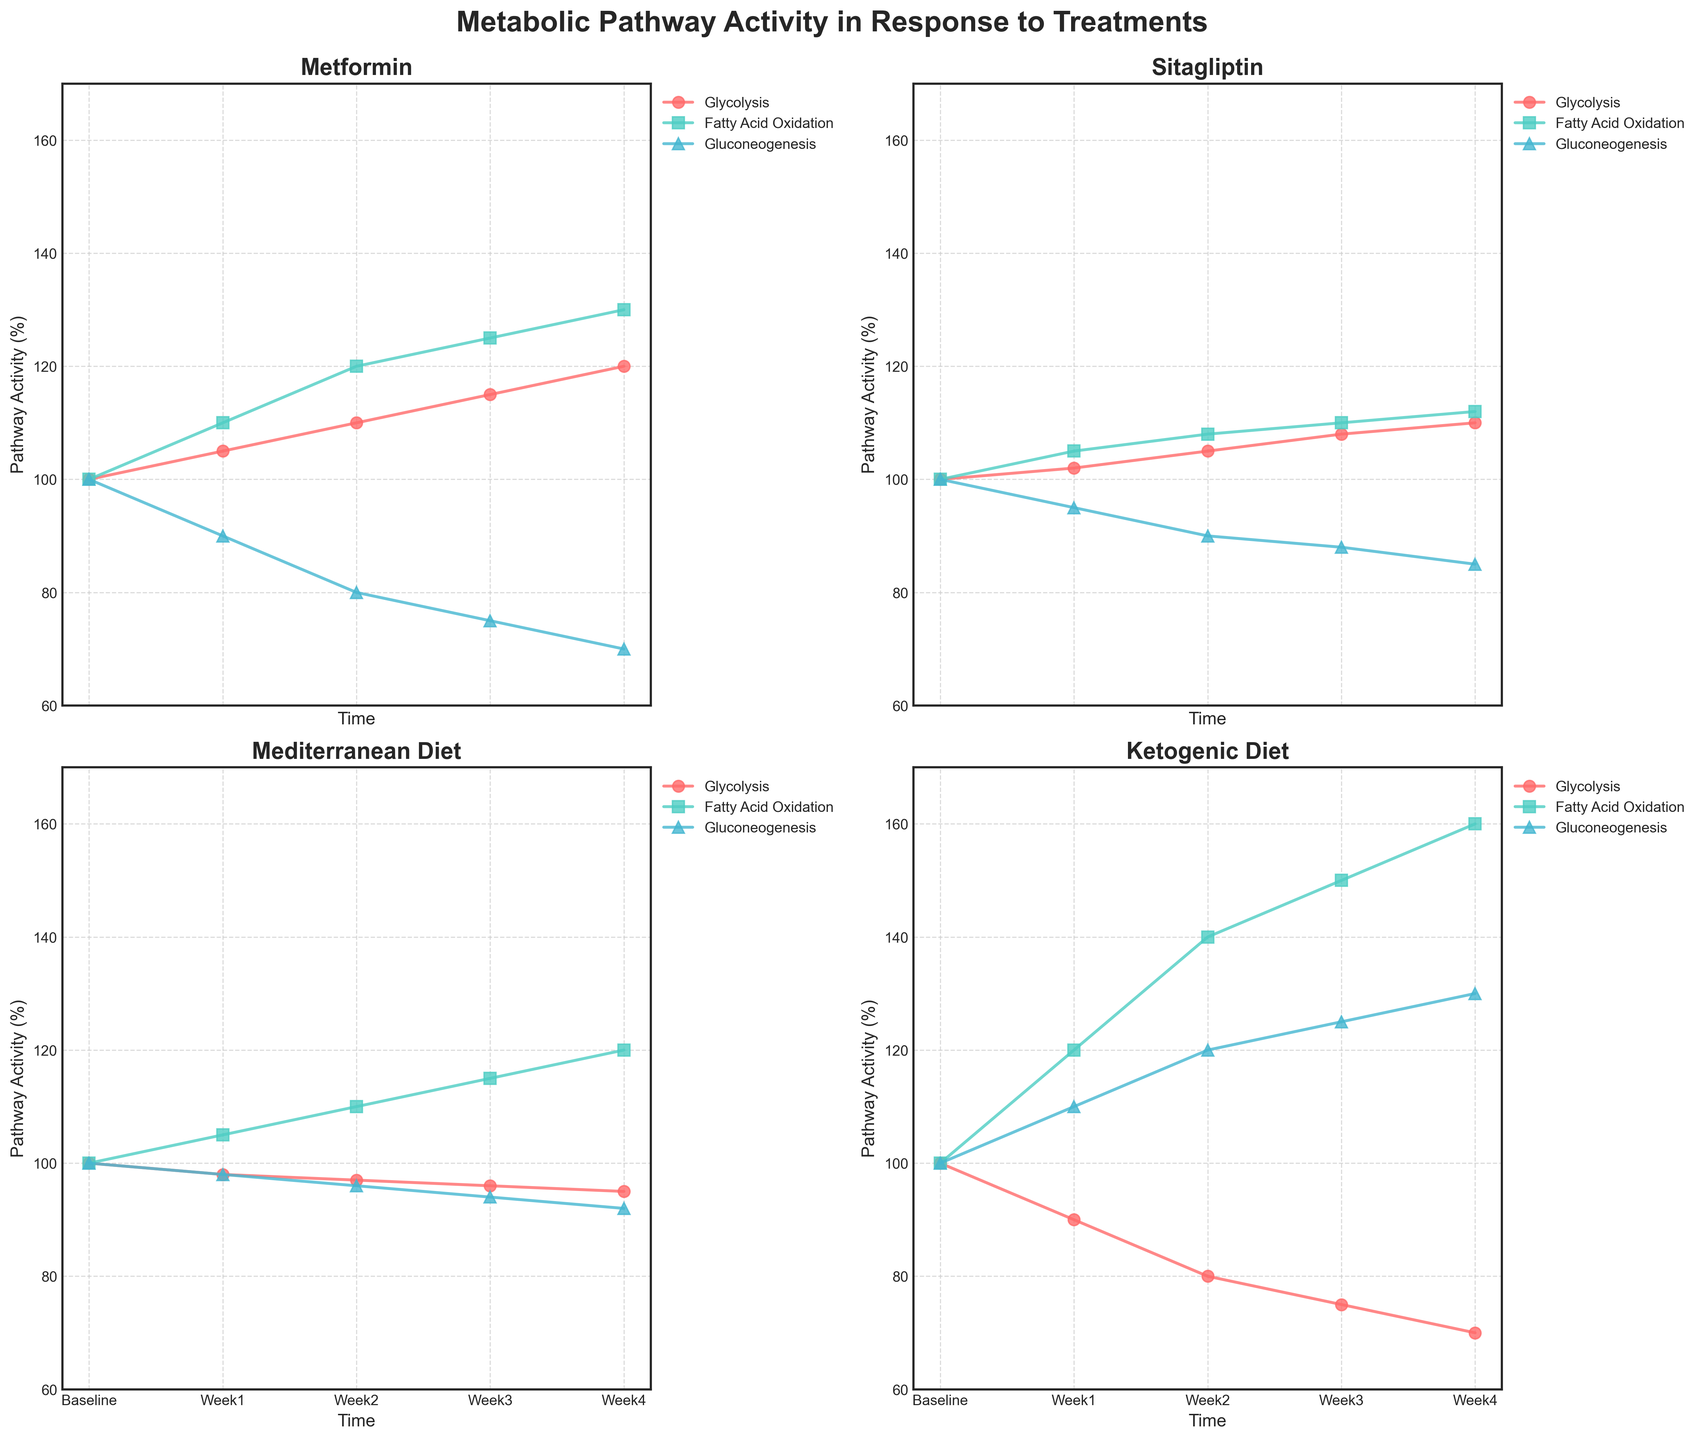What is the y-axis label in all subplots? All subplots have the y-axis labeled as 'Pathway Activity (%)', indicating the activity level of various metabolic pathways as a percentage.
Answer: Pathway Activity (%) Which treatment shows the greatest increase in Glycolysis activity by Week 4? Comparing the Glycolysis activity for all treatments at Week 4: Metformin (120), Sitagliptin (110), Mediterranean Diet (95), and Ketogenic Diet (70). Metformin shows the greatest increase.
Answer: Metformin What is the difference in Fatty Acid Oxidation activity between Week 1 and Week 4 for the Mediterranean Diet treatment? For the Mediterranean Diet treatment, Fatty Acid Oxidation activity is 105 at Week 1 and 120 at Week 4. The difference is 120 - 105 = 15.
Answer: 15 Which pathway shows the greatest decrease in activity from Baseline to Week 4 in any treatment? Comparing the decreases from Baseline to Week 4: Metformin (Gluconeogenesis: 100 -> 70 = 30), Sitagliptin (Gluconeogenesis: 100 -> 85 = 15), Mediterranean Diet (Glycolysis: 100 -> 95 = 5), and Ketogenic Diet (Glycolysis: 100 -> 70 = 30). Metformin Gluconeogenesis and Ketogenic Diet Glycolysis both show a 30-unit decrease.
Answer: Metformin Gluconeogenesis and Ketogenic Diet Glycolysis Compare the change in Gluconeogenesis activity over time for Metformin and Ketogenic Diet treatments. Which decreases more rapidly? Metformin Gluconeogenesis: 100 -> 90 -> 80 -> 75 -> 70. Ketogenic Diet Gluconeogenesis: 100 -> 110 -> 120 -> 125 -> 130. Metformin shows a steady decrease while Ketogenic Diet shows an increase.
Answer: Metformin Which treatment shows the most significant variance in Fatty Acid Oxidation activity from Baseline to Week 4? Comparing the variances: Metformin (100 -> 130), Sitagliptin (100 -> 112), Mediterranean Diet (100 -> 120), and Ketogenic Diet (100 -> 160). Ketogenic Diet shows the most significant variance (60 units).
Answer: Ketogenic Diet What is the minimum activity level observed across all pathways and treatments by Week 4? Comparing values at Week 4 across all pathways and treatments: The minimum value is 70 found in Metformin Gluconeogenesis and Ketogenic Diet Glycolysis.
Answer: 70 Which treatments show a consistent increase in Fatty Acid Oxidation activity over time? Analyzing Fatty Acid Oxidation activity trends over time: Metformin (100 -> 130), Sitagliptin (100 -> 112), Mediterranean Diet (100 -> 120), and Ketogenic Diet (100 -> 160). All treatments show a consistent increase.
Answer: Metformin, Sitagliptin, Mediterranean Diet, and Ketogenic Diet What is the average Week 3 activity level for Glycolysis across all treatments? The Glycolysis Week 3 values are: Metformin (115), Sitagliptin (108), Mediterranean Diet (96), and Ketogenic Diet (75). The average is (115 + 108 + 96 + 75) / 4 = 98.5.
Answer: 98.5 